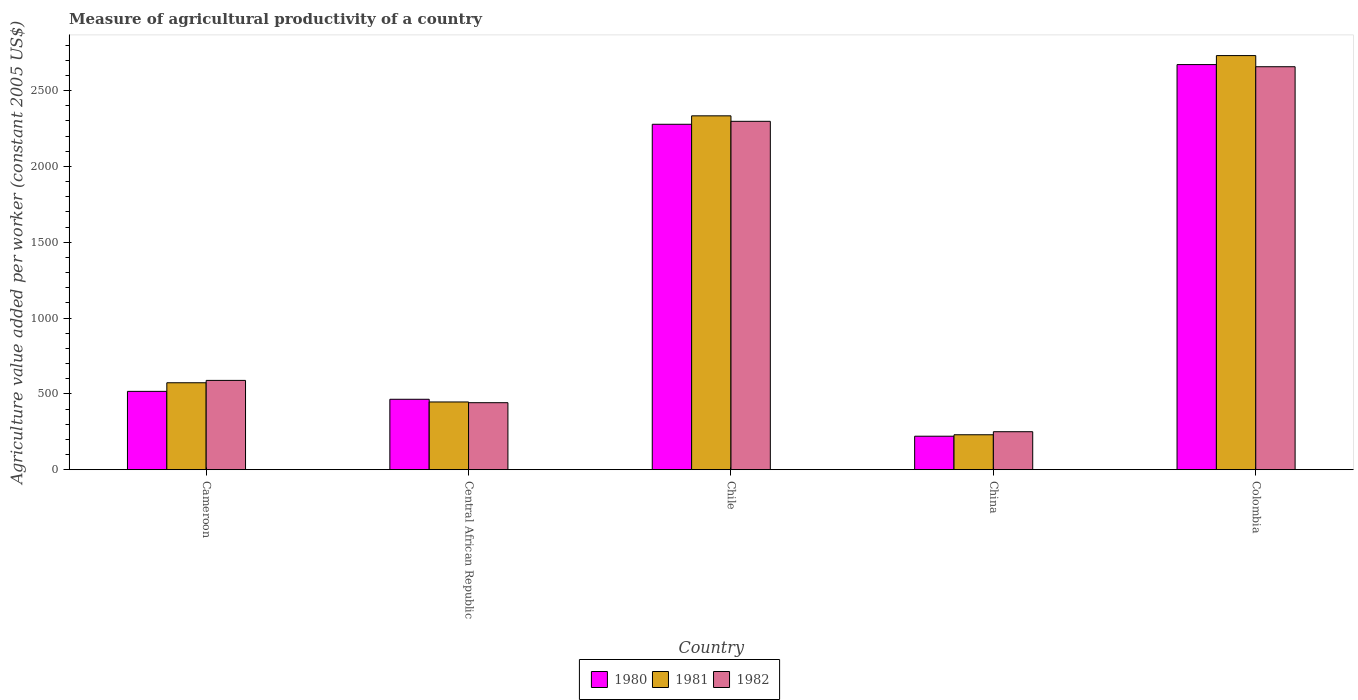How many different coloured bars are there?
Give a very brief answer. 3. How many groups of bars are there?
Give a very brief answer. 5. Are the number of bars per tick equal to the number of legend labels?
Provide a short and direct response. Yes. What is the measure of agricultural productivity in 1982 in China?
Your answer should be compact. 250.55. Across all countries, what is the maximum measure of agricultural productivity in 1982?
Offer a terse response. 2657.56. Across all countries, what is the minimum measure of agricultural productivity in 1981?
Provide a succinct answer. 230.38. In which country was the measure of agricultural productivity in 1980 minimum?
Make the answer very short. China. What is the total measure of agricultural productivity in 1980 in the graph?
Make the answer very short. 6151.49. What is the difference between the measure of agricultural productivity in 1982 in Central African Republic and that in Colombia?
Provide a succinct answer. -2215.64. What is the difference between the measure of agricultural productivity in 1982 in Cameroon and the measure of agricultural productivity in 1981 in Central African Republic?
Keep it short and to the point. 142.2. What is the average measure of agricultural productivity in 1980 per country?
Provide a short and direct response. 1230.3. What is the difference between the measure of agricultural productivity of/in 1982 and measure of agricultural productivity of/in 1980 in China?
Your response must be concise. 29.7. In how many countries, is the measure of agricultural productivity in 1982 greater than 200 US$?
Your answer should be very brief. 5. What is the ratio of the measure of agricultural productivity in 1980 in Central African Republic to that in Colombia?
Your response must be concise. 0.17. Is the difference between the measure of agricultural productivity in 1982 in China and Colombia greater than the difference between the measure of agricultural productivity in 1980 in China and Colombia?
Your answer should be compact. Yes. What is the difference between the highest and the second highest measure of agricultural productivity in 1981?
Your answer should be very brief. -2157.7. What is the difference between the highest and the lowest measure of agricultural productivity in 1981?
Provide a short and direct response. 2500.64. What does the 1st bar from the left in Central African Republic represents?
Your answer should be very brief. 1980. What does the 3rd bar from the right in Colombia represents?
Make the answer very short. 1980. What is the difference between two consecutive major ticks on the Y-axis?
Provide a short and direct response. 500. Where does the legend appear in the graph?
Make the answer very short. Bottom center. How many legend labels are there?
Give a very brief answer. 3. What is the title of the graph?
Offer a very short reply. Measure of agricultural productivity of a country. What is the label or title of the Y-axis?
Make the answer very short. Agriculture value added per worker (constant 2005 US$). What is the Agriculture value added per worker (constant 2005 US$) in 1980 in Cameroon?
Provide a short and direct response. 516.62. What is the Agriculture value added per worker (constant 2005 US$) in 1981 in Cameroon?
Provide a succinct answer. 573.32. What is the Agriculture value added per worker (constant 2005 US$) in 1982 in Cameroon?
Keep it short and to the point. 588.87. What is the Agriculture value added per worker (constant 2005 US$) in 1980 in Central African Republic?
Offer a terse response. 464.44. What is the Agriculture value added per worker (constant 2005 US$) of 1981 in Central African Republic?
Provide a succinct answer. 446.67. What is the Agriculture value added per worker (constant 2005 US$) of 1982 in Central African Republic?
Ensure brevity in your answer.  441.92. What is the Agriculture value added per worker (constant 2005 US$) of 1980 in Chile?
Offer a terse response. 2277.98. What is the Agriculture value added per worker (constant 2005 US$) of 1981 in Chile?
Your response must be concise. 2333.68. What is the Agriculture value added per worker (constant 2005 US$) in 1982 in Chile?
Give a very brief answer. 2297.45. What is the Agriculture value added per worker (constant 2005 US$) of 1980 in China?
Give a very brief answer. 220.85. What is the Agriculture value added per worker (constant 2005 US$) in 1981 in China?
Your response must be concise. 230.38. What is the Agriculture value added per worker (constant 2005 US$) in 1982 in China?
Provide a short and direct response. 250.55. What is the Agriculture value added per worker (constant 2005 US$) of 1980 in Colombia?
Provide a succinct answer. 2671.6. What is the Agriculture value added per worker (constant 2005 US$) of 1981 in Colombia?
Make the answer very short. 2731.02. What is the Agriculture value added per worker (constant 2005 US$) of 1982 in Colombia?
Provide a short and direct response. 2657.56. Across all countries, what is the maximum Agriculture value added per worker (constant 2005 US$) of 1980?
Offer a very short reply. 2671.6. Across all countries, what is the maximum Agriculture value added per worker (constant 2005 US$) in 1981?
Offer a terse response. 2731.02. Across all countries, what is the maximum Agriculture value added per worker (constant 2005 US$) in 1982?
Ensure brevity in your answer.  2657.56. Across all countries, what is the minimum Agriculture value added per worker (constant 2005 US$) of 1980?
Your response must be concise. 220.85. Across all countries, what is the minimum Agriculture value added per worker (constant 2005 US$) in 1981?
Provide a short and direct response. 230.38. Across all countries, what is the minimum Agriculture value added per worker (constant 2005 US$) in 1982?
Your answer should be very brief. 250.55. What is the total Agriculture value added per worker (constant 2005 US$) of 1980 in the graph?
Keep it short and to the point. 6151.49. What is the total Agriculture value added per worker (constant 2005 US$) of 1981 in the graph?
Provide a succinct answer. 6315.07. What is the total Agriculture value added per worker (constant 2005 US$) in 1982 in the graph?
Provide a succinct answer. 6236.36. What is the difference between the Agriculture value added per worker (constant 2005 US$) of 1980 in Cameroon and that in Central African Republic?
Give a very brief answer. 52.18. What is the difference between the Agriculture value added per worker (constant 2005 US$) of 1981 in Cameroon and that in Central African Republic?
Your answer should be very brief. 126.65. What is the difference between the Agriculture value added per worker (constant 2005 US$) in 1982 in Cameroon and that in Central African Republic?
Make the answer very short. 146.95. What is the difference between the Agriculture value added per worker (constant 2005 US$) in 1980 in Cameroon and that in Chile?
Offer a terse response. -1761.37. What is the difference between the Agriculture value added per worker (constant 2005 US$) of 1981 in Cameroon and that in Chile?
Keep it short and to the point. -1760.36. What is the difference between the Agriculture value added per worker (constant 2005 US$) of 1982 in Cameroon and that in Chile?
Offer a very short reply. -1708.58. What is the difference between the Agriculture value added per worker (constant 2005 US$) of 1980 in Cameroon and that in China?
Your answer should be very brief. 295.76. What is the difference between the Agriculture value added per worker (constant 2005 US$) of 1981 in Cameroon and that in China?
Offer a very short reply. 342.94. What is the difference between the Agriculture value added per worker (constant 2005 US$) in 1982 in Cameroon and that in China?
Your response must be concise. 338.32. What is the difference between the Agriculture value added per worker (constant 2005 US$) in 1980 in Cameroon and that in Colombia?
Ensure brevity in your answer.  -2154.98. What is the difference between the Agriculture value added per worker (constant 2005 US$) of 1981 in Cameroon and that in Colombia?
Offer a very short reply. -2157.7. What is the difference between the Agriculture value added per worker (constant 2005 US$) in 1982 in Cameroon and that in Colombia?
Give a very brief answer. -2068.69. What is the difference between the Agriculture value added per worker (constant 2005 US$) in 1980 in Central African Republic and that in Chile?
Your answer should be very brief. -1813.54. What is the difference between the Agriculture value added per worker (constant 2005 US$) of 1981 in Central African Republic and that in Chile?
Keep it short and to the point. -1887.01. What is the difference between the Agriculture value added per worker (constant 2005 US$) in 1982 in Central African Republic and that in Chile?
Provide a short and direct response. -1855.53. What is the difference between the Agriculture value added per worker (constant 2005 US$) of 1980 in Central African Republic and that in China?
Offer a terse response. 243.59. What is the difference between the Agriculture value added per worker (constant 2005 US$) of 1981 in Central African Republic and that in China?
Offer a terse response. 216.29. What is the difference between the Agriculture value added per worker (constant 2005 US$) in 1982 in Central African Republic and that in China?
Your answer should be compact. 191.37. What is the difference between the Agriculture value added per worker (constant 2005 US$) in 1980 in Central African Republic and that in Colombia?
Offer a very short reply. -2207.16. What is the difference between the Agriculture value added per worker (constant 2005 US$) in 1981 in Central African Republic and that in Colombia?
Ensure brevity in your answer.  -2284.35. What is the difference between the Agriculture value added per worker (constant 2005 US$) of 1982 in Central African Republic and that in Colombia?
Your answer should be very brief. -2215.64. What is the difference between the Agriculture value added per worker (constant 2005 US$) of 1980 in Chile and that in China?
Keep it short and to the point. 2057.13. What is the difference between the Agriculture value added per worker (constant 2005 US$) of 1981 in Chile and that in China?
Keep it short and to the point. 2103.3. What is the difference between the Agriculture value added per worker (constant 2005 US$) of 1982 in Chile and that in China?
Keep it short and to the point. 2046.9. What is the difference between the Agriculture value added per worker (constant 2005 US$) of 1980 in Chile and that in Colombia?
Give a very brief answer. -393.61. What is the difference between the Agriculture value added per worker (constant 2005 US$) of 1981 in Chile and that in Colombia?
Give a very brief answer. -397.34. What is the difference between the Agriculture value added per worker (constant 2005 US$) in 1982 in Chile and that in Colombia?
Offer a terse response. -360.11. What is the difference between the Agriculture value added per worker (constant 2005 US$) in 1980 in China and that in Colombia?
Ensure brevity in your answer.  -2450.74. What is the difference between the Agriculture value added per worker (constant 2005 US$) of 1981 in China and that in Colombia?
Offer a terse response. -2500.64. What is the difference between the Agriculture value added per worker (constant 2005 US$) of 1982 in China and that in Colombia?
Offer a terse response. -2407.01. What is the difference between the Agriculture value added per worker (constant 2005 US$) in 1980 in Cameroon and the Agriculture value added per worker (constant 2005 US$) in 1981 in Central African Republic?
Make the answer very short. 69.94. What is the difference between the Agriculture value added per worker (constant 2005 US$) in 1980 in Cameroon and the Agriculture value added per worker (constant 2005 US$) in 1982 in Central African Republic?
Your answer should be compact. 74.7. What is the difference between the Agriculture value added per worker (constant 2005 US$) of 1981 in Cameroon and the Agriculture value added per worker (constant 2005 US$) of 1982 in Central African Republic?
Provide a succinct answer. 131.4. What is the difference between the Agriculture value added per worker (constant 2005 US$) in 1980 in Cameroon and the Agriculture value added per worker (constant 2005 US$) in 1981 in Chile?
Make the answer very short. -1817.07. What is the difference between the Agriculture value added per worker (constant 2005 US$) in 1980 in Cameroon and the Agriculture value added per worker (constant 2005 US$) in 1982 in Chile?
Your response must be concise. -1780.84. What is the difference between the Agriculture value added per worker (constant 2005 US$) of 1981 in Cameroon and the Agriculture value added per worker (constant 2005 US$) of 1982 in Chile?
Provide a succinct answer. -1724.13. What is the difference between the Agriculture value added per worker (constant 2005 US$) of 1980 in Cameroon and the Agriculture value added per worker (constant 2005 US$) of 1981 in China?
Your answer should be compact. 286.23. What is the difference between the Agriculture value added per worker (constant 2005 US$) in 1980 in Cameroon and the Agriculture value added per worker (constant 2005 US$) in 1982 in China?
Offer a terse response. 266.06. What is the difference between the Agriculture value added per worker (constant 2005 US$) of 1981 in Cameroon and the Agriculture value added per worker (constant 2005 US$) of 1982 in China?
Offer a very short reply. 322.77. What is the difference between the Agriculture value added per worker (constant 2005 US$) in 1980 in Cameroon and the Agriculture value added per worker (constant 2005 US$) in 1981 in Colombia?
Your answer should be very brief. -2214.4. What is the difference between the Agriculture value added per worker (constant 2005 US$) of 1980 in Cameroon and the Agriculture value added per worker (constant 2005 US$) of 1982 in Colombia?
Your response must be concise. -2140.95. What is the difference between the Agriculture value added per worker (constant 2005 US$) of 1981 in Cameroon and the Agriculture value added per worker (constant 2005 US$) of 1982 in Colombia?
Provide a succinct answer. -2084.24. What is the difference between the Agriculture value added per worker (constant 2005 US$) of 1980 in Central African Republic and the Agriculture value added per worker (constant 2005 US$) of 1981 in Chile?
Provide a succinct answer. -1869.24. What is the difference between the Agriculture value added per worker (constant 2005 US$) of 1980 in Central African Republic and the Agriculture value added per worker (constant 2005 US$) of 1982 in Chile?
Provide a short and direct response. -1833.01. What is the difference between the Agriculture value added per worker (constant 2005 US$) of 1981 in Central African Republic and the Agriculture value added per worker (constant 2005 US$) of 1982 in Chile?
Your response must be concise. -1850.78. What is the difference between the Agriculture value added per worker (constant 2005 US$) in 1980 in Central African Republic and the Agriculture value added per worker (constant 2005 US$) in 1981 in China?
Offer a very short reply. 234.06. What is the difference between the Agriculture value added per worker (constant 2005 US$) of 1980 in Central African Republic and the Agriculture value added per worker (constant 2005 US$) of 1982 in China?
Keep it short and to the point. 213.89. What is the difference between the Agriculture value added per worker (constant 2005 US$) of 1981 in Central African Republic and the Agriculture value added per worker (constant 2005 US$) of 1982 in China?
Your answer should be very brief. 196.12. What is the difference between the Agriculture value added per worker (constant 2005 US$) of 1980 in Central African Republic and the Agriculture value added per worker (constant 2005 US$) of 1981 in Colombia?
Your response must be concise. -2266.58. What is the difference between the Agriculture value added per worker (constant 2005 US$) in 1980 in Central African Republic and the Agriculture value added per worker (constant 2005 US$) in 1982 in Colombia?
Keep it short and to the point. -2193.12. What is the difference between the Agriculture value added per worker (constant 2005 US$) of 1981 in Central African Republic and the Agriculture value added per worker (constant 2005 US$) of 1982 in Colombia?
Your answer should be compact. -2210.89. What is the difference between the Agriculture value added per worker (constant 2005 US$) of 1980 in Chile and the Agriculture value added per worker (constant 2005 US$) of 1981 in China?
Your answer should be very brief. 2047.6. What is the difference between the Agriculture value added per worker (constant 2005 US$) in 1980 in Chile and the Agriculture value added per worker (constant 2005 US$) in 1982 in China?
Your response must be concise. 2027.43. What is the difference between the Agriculture value added per worker (constant 2005 US$) of 1981 in Chile and the Agriculture value added per worker (constant 2005 US$) of 1982 in China?
Ensure brevity in your answer.  2083.13. What is the difference between the Agriculture value added per worker (constant 2005 US$) of 1980 in Chile and the Agriculture value added per worker (constant 2005 US$) of 1981 in Colombia?
Provide a short and direct response. -453.04. What is the difference between the Agriculture value added per worker (constant 2005 US$) of 1980 in Chile and the Agriculture value added per worker (constant 2005 US$) of 1982 in Colombia?
Provide a succinct answer. -379.58. What is the difference between the Agriculture value added per worker (constant 2005 US$) in 1981 in Chile and the Agriculture value added per worker (constant 2005 US$) in 1982 in Colombia?
Offer a terse response. -323.88. What is the difference between the Agriculture value added per worker (constant 2005 US$) of 1980 in China and the Agriculture value added per worker (constant 2005 US$) of 1981 in Colombia?
Ensure brevity in your answer.  -2510.17. What is the difference between the Agriculture value added per worker (constant 2005 US$) of 1980 in China and the Agriculture value added per worker (constant 2005 US$) of 1982 in Colombia?
Offer a terse response. -2436.71. What is the difference between the Agriculture value added per worker (constant 2005 US$) of 1981 in China and the Agriculture value added per worker (constant 2005 US$) of 1982 in Colombia?
Offer a very short reply. -2427.18. What is the average Agriculture value added per worker (constant 2005 US$) of 1980 per country?
Ensure brevity in your answer.  1230.3. What is the average Agriculture value added per worker (constant 2005 US$) in 1981 per country?
Make the answer very short. 1263.01. What is the average Agriculture value added per worker (constant 2005 US$) in 1982 per country?
Give a very brief answer. 1247.27. What is the difference between the Agriculture value added per worker (constant 2005 US$) of 1980 and Agriculture value added per worker (constant 2005 US$) of 1981 in Cameroon?
Provide a short and direct response. -56.7. What is the difference between the Agriculture value added per worker (constant 2005 US$) of 1980 and Agriculture value added per worker (constant 2005 US$) of 1982 in Cameroon?
Keep it short and to the point. -72.26. What is the difference between the Agriculture value added per worker (constant 2005 US$) in 1981 and Agriculture value added per worker (constant 2005 US$) in 1982 in Cameroon?
Your response must be concise. -15.55. What is the difference between the Agriculture value added per worker (constant 2005 US$) in 1980 and Agriculture value added per worker (constant 2005 US$) in 1981 in Central African Republic?
Your response must be concise. 17.77. What is the difference between the Agriculture value added per worker (constant 2005 US$) in 1980 and Agriculture value added per worker (constant 2005 US$) in 1982 in Central African Republic?
Your answer should be very brief. 22.52. What is the difference between the Agriculture value added per worker (constant 2005 US$) of 1981 and Agriculture value added per worker (constant 2005 US$) of 1982 in Central African Republic?
Ensure brevity in your answer.  4.75. What is the difference between the Agriculture value added per worker (constant 2005 US$) of 1980 and Agriculture value added per worker (constant 2005 US$) of 1981 in Chile?
Provide a succinct answer. -55.7. What is the difference between the Agriculture value added per worker (constant 2005 US$) of 1980 and Agriculture value added per worker (constant 2005 US$) of 1982 in Chile?
Ensure brevity in your answer.  -19.47. What is the difference between the Agriculture value added per worker (constant 2005 US$) in 1981 and Agriculture value added per worker (constant 2005 US$) in 1982 in Chile?
Offer a very short reply. 36.23. What is the difference between the Agriculture value added per worker (constant 2005 US$) of 1980 and Agriculture value added per worker (constant 2005 US$) of 1981 in China?
Offer a very short reply. -9.53. What is the difference between the Agriculture value added per worker (constant 2005 US$) of 1980 and Agriculture value added per worker (constant 2005 US$) of 1982 in China?
Give a very brief answer. -29.7. What is the difference between the Agriculture value added per worker (constant 2005 US$) of 1981 and Agriculture value added per worker (constant 2005 US$) of 1982 in China?
Your response must be concise. -20.17. What is the difference between the Agriculture value added per worker (constant 2005 US$) in 1980 and Agriculture value added per worker (constant 2005 US$) in 1981 in Colombia?
Keep it short and to the point. -59.42. What is the difference between the Agriculture value added per worker (constant 2005 US$) in 1980 and Agriculture value added per worker (constant 2005 US$) in 1982 in Colombia?
Your answer should be compact. 14.03. What is the difference between the Agriculture value added per worker (constant 2005 US$) in 1981 and Agriculture value added per worker (constant 2005 US$) in 1982 in Colombia?
Ensure brevity in your answer.  73.46. What is the ratio of the Agriculture value added per worker (constant 2005 US$) in 1980 in Cameroon to that in Central African Republic?
Provide a succinct answer. 1.11. What is the ratio of the Agriculture value added per worker (constant 2005 US$) in 1981 in Cameroon to that in Central African Republic?
Ensure brevity in your answer.  1.28. What is the ratio of the Agriculture value added per worker (constant 2005 US$) in 1982 in Cameroon to that in Central African Republic?
Provide a succinct answer. 1.33. What is the ratio of the Agriculture value added per worker (constant 2005 US$) of 1980 in Cameroon to that in Chile?
Offer a very short reply. 0.23. What is the ratio of the Agriculture value added per worker (constant 2005 US$) of 1981 in Cameroon to that in Chile?
Your answer should be very brief. 0.25. What is the ratio of the Agriculture value added per worker (constant 2005 US$) of 1982 in Cameroon to that in Chile?
Keep it short and to the point. 0.26. What is the ratio of the Agriculture value added per worker (constant 2005 US$) in 1980 in Cameroon to that in China?
Ensure brevity in your answer.  2.34. What is the ratio of the Agriculture value added per worker (constant 2005 US$) of 1981 in Cameroon to that in China?
Offer a terse response. 2.49. What is the ratio of the Agriculture value added per worker (constant 2005 US$) in 1982 in Cameroon to that in China?
Your answer should be compact. 2.35. What is the ratio of the Agriculture value added per worker (constant 2005 US$) in 1980 in Cameroon to that in Colombia?
Your answer should be compact. 0.19. What is the ratio of the Agriculture value added per worker (constant 2005 US$) in 1981 in Cameroon to that in Colombia?
Your response must be concise. 0.21. What is the ratio of the Agriculture value added per worker (constant 2005 US$) in 1982 in Cameroon to that in Colombia?
Offer a very short reply. 0.22. What is the ratio of the Agriculture value added per worker (constant 2005 US$) in 1980 in Central African Republic to that in Chile?
Offer a very short reply. 0.2. What is the ratio of the Agriculture value added per worker (constant 2005 US$) of 1981 in Central African Republic to that in Chile?
Keep it short and to the point. 0.19. What is the ratio of the Agriculture value added per worker (constant 2005 US$) in 1982 in Central African Republic to that in Chile?
Make the answer very short. 0.19. What is the ratio of the Agriculture value added per worker (constant 2005 US$) of 1980 in Central African Republic to that in China?
Your answer should be compact. 2.1. What is the ratio of the Agriculture value added per worker (constant 2005 US$) in 1981 in Central African Republic to that in China?
Make the answer very short. 1.94. What is the ratio of the Agriculture value added per worker (constant 2005 US$) in 1982 in Central African Republic to that in China?
Provide a short and direct response. 1.76. What is the ratio of the Agriculture value added per worker (constant 2005 US$) of 1980 in Central African Republic to that in Colombia?
Provide a short and direct response. 0.17. What is the ratio of the Agriculture value added per worker (constant 2005 US$) in 1981 in Central African Republic to that in Colombia?
Make the answer very short. 0.16. What is the ratio of the Agriculture value added per worker (constant 2005 US$) of 1982 in Central African Republic to that in Colombia?
Your answer should be very brief. 0.17. What is the ratio of the Agriculture value added per worker (constant 2005 US$) of 1980 in Chile to that in China?
Your answer should be compact. 10.31. What is the ratio of the Agriculture value added per worker (constant 2005 US$) in 1981 in Chile to that in China?
Your answer should be very brief. 10.13. What is the ratio of the Agriculture value added per worker (constant 2005 US$) in 1982 in Chile to that in China?
Offer a very short reply. 9.17. What is the ratio of the Agriculture value added per worker (constant 2005 US$) in 1980 in Chile to that in Colombia?
Your answer should be very brief. 0.85. What is the ratio of the Agriculture value added per worker (constant 2005 US$) in 1981 in Chile to that in Colombia?
Your response must be concise. 0.85. What is the ratio of the Agriculture value added per worker (constant 2005 US$) of 1982 in Chile to that in Colombia?
Your response must be concise. 0.86. What is the ratio of the Agriculture value added per worker (constant 2005 US$) in 1980 in China to that in Colombia?
Offer a very short reply. 0.08. What is the ratio of the Agriculture value added per worker (constant 2005 US$) in 1981 in China to that in Colombia?
Give a very brief answer. 0.08. What is the ratio of the Agriculture value added per worker (constant 2005 US$) of 1982 in China to that in Colombia?
Your answer should be very brief. 0.09. What is the difference between the highest and the second highest Agriculture value added per worker (constant 2005 US$) of 1980?
Give a very brief answer. 393.61. What is the difference between the highest and the second highest Agriculture value added per worker (constant 2005 US$) of 1981?
Provide a succinct answer. 397.34. What is the difference between the highest and the second highest Agriculture value added per worker (constant 2005 US$) of 1982?
Ensure brevity in your answer.  360.11. What is the difference between the highest and the lowest Agriculture value added per worker (constant 2005 US$) of 1980?
Offer a terse response. 2450.74. What is the difference between the highest and the lowest Agriculture value added per worker (constant 2005 US$) of 1981?
Your answer should be compact. 2500.64. What is the difference between the highest and the lowest Agriculture value added per worker (constant 2005 US$) of 1982?
Provide a short and direct response. 2407.01. 